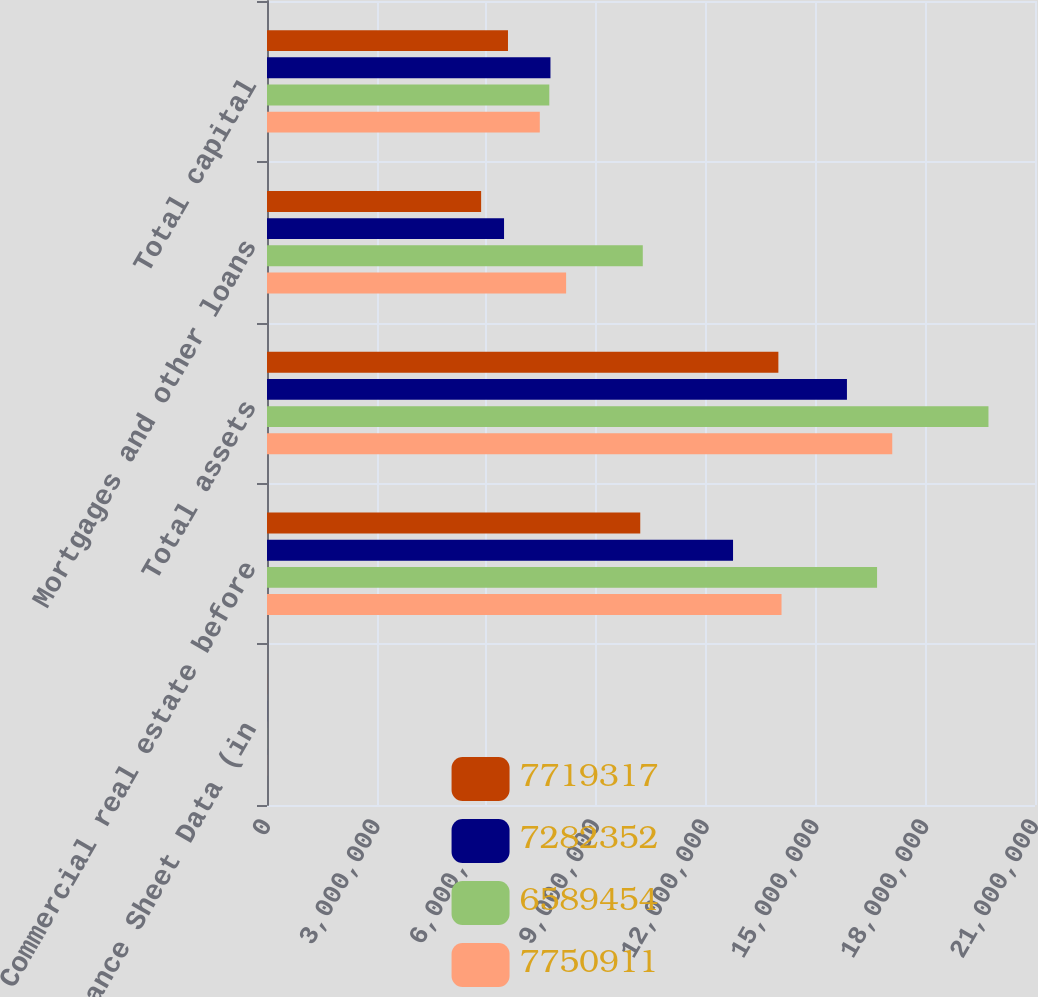Convert chart to OTSL. <chart><loc_0><loc_0><loc_500><loc_500><stacked_bar_chart><ecel><fcel>Balance Sheet Data (in<fcel>Commercial real estate before<fcel>Total assets<fcel>Mortgages and other loans<fcel>Total capital<nl><fcel>7.71932e+06<fcel>2017<fcel>1.02061e+07<fcel>1.39829e+07<fcel>5.85513e+06<fcel>6.58945e+06<nl><fcel>7.28235e+06<fcel>2016<fcel>1.27433e+07<fcel>1.58578e+07<fcel>6.48167e+06<fcel>7.75091e+06<nl><fcel>6.58945e+06<fcel>2015<fcel>1.66816e+07<fcel>1.97276e+07<fcel>1.02755e+07<fcel>7.71932e+06<nl><fcel>7.75091e+06<fcel>2014<fcel>1.40691e+07<fcel>1.70966e+07<fcel>8.17879e+06<fcel>7.45922e+06<nl></chart> 